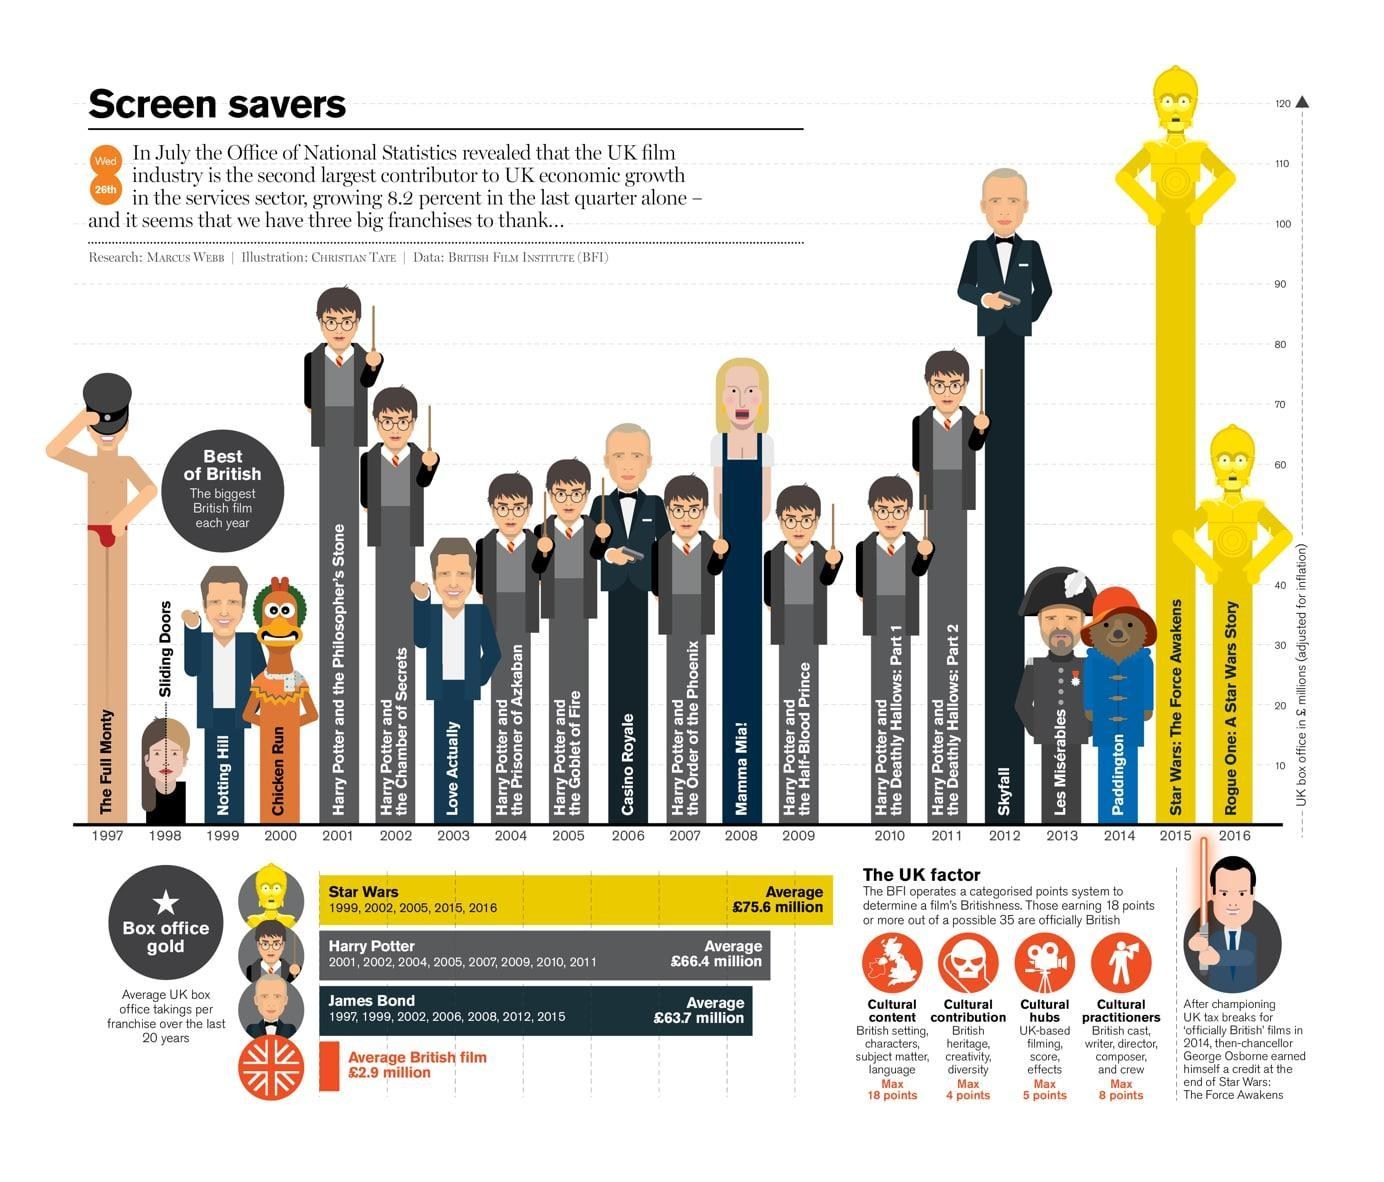When was the movie 'Sliding Doors' released by the British films?
Answer the question with a short phrase. 1998 Which movie crossed over 120 million pounds at the UK box office? Star Wars: The Force Awakens What is the average revenue generated by the James Bond series at UK box office? £63.7 million What is the average revenue generated by the Harry Potter series at UK box office? £66.4 million Which animation movie was released by the UK film industry in 2014? Paddington What is the average revenue generated by the British films? £2.9 million When was the last Harry Potter Film Series released? 2011 Which was the first movie to cross over 100 million pound mark in UK? Skyfall Which animation movie was released by the UK film industry in 2000? Chicken Run When was the first Harry Potter Film Series released? 2001 